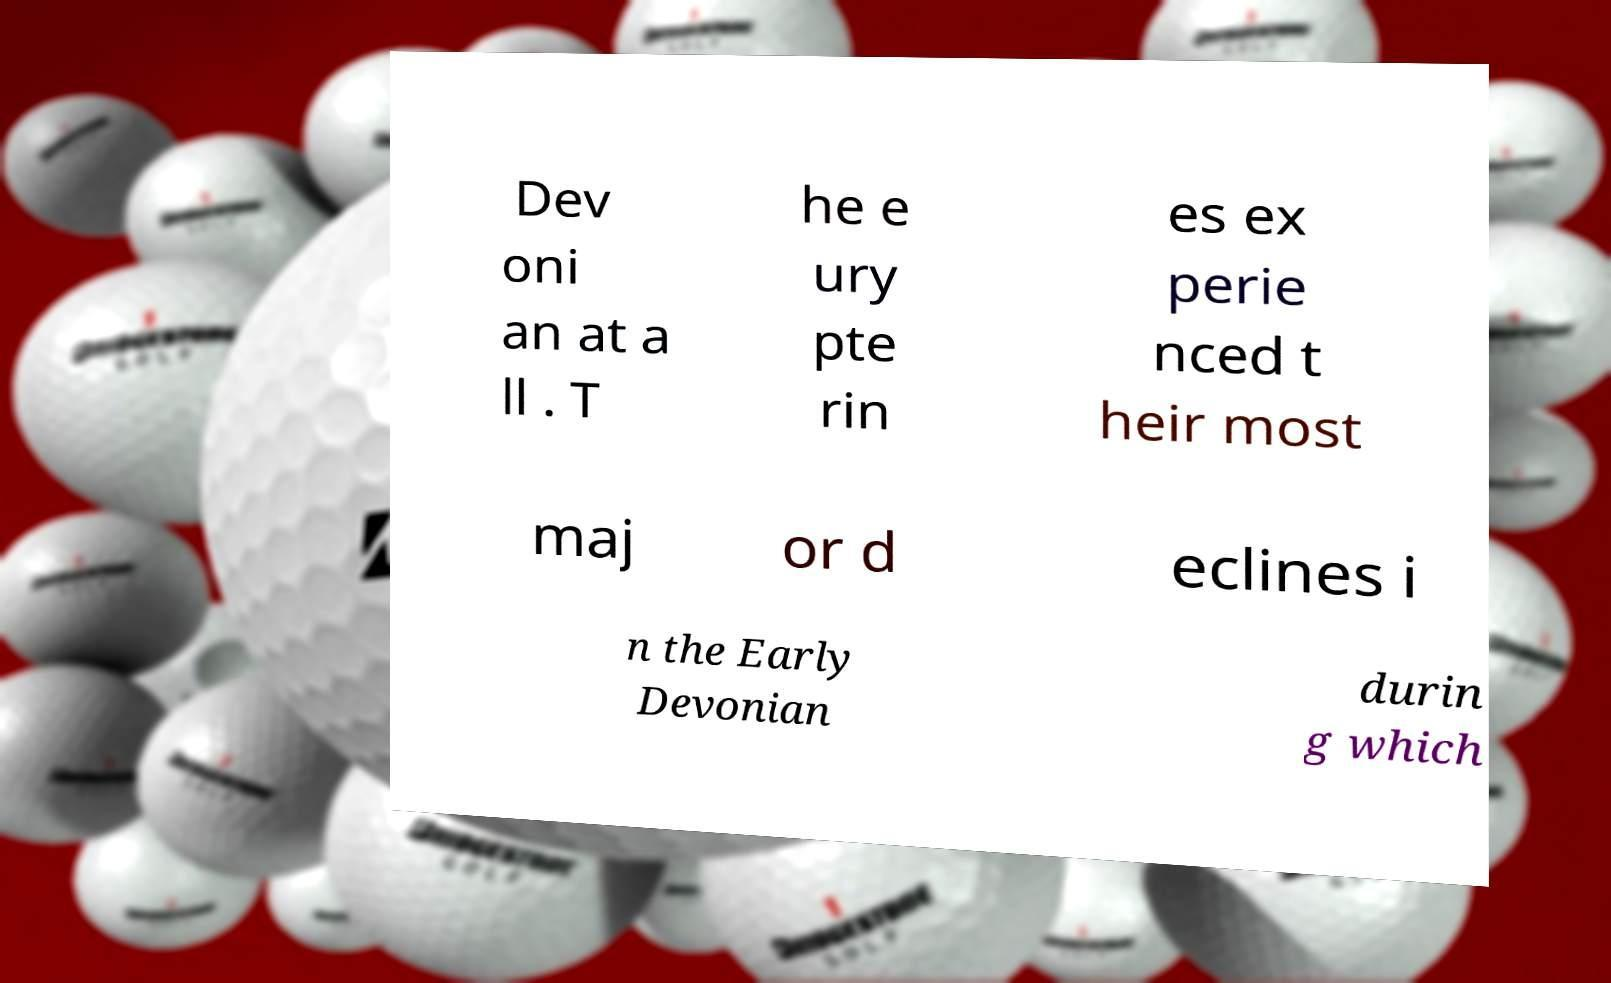Please identify and transcribe the text found in this image. Dev oni an at a ll . T he e ury pte rin es ex perie nced t heir most maj or d eclines i n the Early Devonian durin g which 